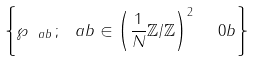Convert formula to latex. <formula><loc_0><loc_0><loc_500><loc_500>\left \{ \wp _ { \ a b } \, ; \, { \ a b } \in \left ( \frac { 1 } { N } \mathbb { Z } \slash \mathbb { Z } \right ) ^ { 2 } \ { \ 0 b } \right \}</formula> 